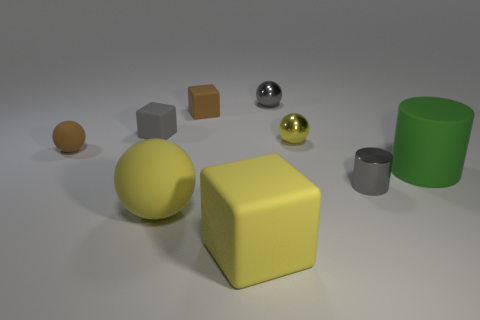Subtract all small brown rubber cubes. How many cubes are left? 2 Subtract all cyan cubes. How many yellow balls are left? 2 Add 1 brown cubes. How many objects exist? 10 Subtract all gray balls. How many balls are left? 3 Subtract 4 balls. How many balls are left? 0 Subtract all cylinders. How many objects are left? 7 Add 1 tiny gray objects. How many tiny gray objects are left? 4 Add 9 large matte spheres. How many large matte spheres exist? 10 Subtract 1 brown spheres. How many objects are left? 8 Subtract all cyan balls. Subtract all purple cubes. How many balls are left? 4 